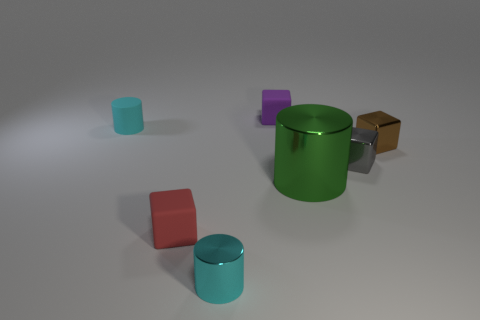What size is the green object?
Your response must be concise. Large. Are there more small gray metal cubes that are to the left of the green object than tiny purple matte blocks that are in front of the rubber cylinder?
Your response must be concise. No. What is the gray object made of?
Your answer should be compact. Metal. What is the shape of the matte thing that is to the right of the tiny rubber cube that is on the left side of the rubber thing behind the rubber cylinder?
Make the answer very short. Cube. How many other things are made of the same material as the purple block?
Provide a succinct answer. 2. Do the small cyan cylinder that is behind the cyan metal cylinder and the cube that is behind the brown cube have the same material?
Offer a very short reply. Yes. How many cubes are in front of the purple matte thing and behind the small red cube?
Provide a succinct answer. 2. Are there any cyan rubber objects that have the same shape as the green object?
Make the answer very short. Yes. There is a red thing that is the same size as the gray shiny thing; what shape is it?
Your answer should be very brief. Cube. Are there the same number of purple rubber blocks in front of the gray metal block and matte things in front of the green shiny cylinder?
Your answer should be compact. No. 